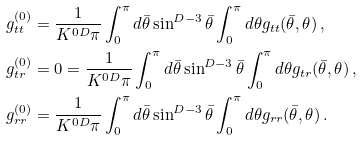Convert formula to latex. <formula><loc_0><loc_0><loc_500><loc_500>g _ { t t } ^ { ( 0 ) } & = \frac { 1 } { K ^ { 0 D } \pi } \int _ { 0 } ^ { \pi } d \bar { \theta } \sin ^ { D - 3 } \bar { \theta } \int _ { 0 } ^ { \pi } d \theta g _ { t t } ( \bar { \theta } , \theta ) \, , \\ g _ { t r } ^ { ( 0 ) } & = 0 = \frac { 1 } { K ^ { 0 D } \pi } \int _ { 0 } ^ { \pi } d \bar { \theta } \sin ^ { D - 3 } \bar { \theta } \int _ { 0 } ^ { \pi } d \theta g _ { t r } ( \bar { \theta } , \theta ) \, , \\ g _ { r r } ^ { ( 0 ) } & = \frac { 1 } { K ^ { 0 D } \pi } \int _ { 0 } ^ { \pi } d \bar { \theta } \sin ^ { D - 3 } \bar { \theta } \int _ { 0 } ^ { \pi } d \theta g _ { r r } ( \bar { \theta } , \theta ) \, .</formula> 